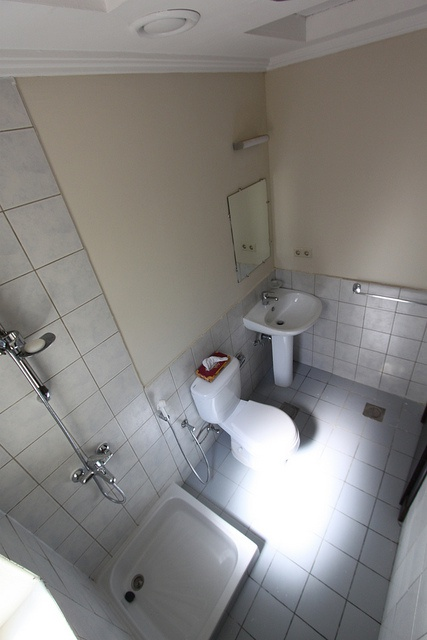Describe the objects in this image and their specific colors. I can see sink in darkgray, gray, and white tones, toilet in darkgray, lavender, and gray tones, and sink in darkgray, gray, and black tones in this image. 